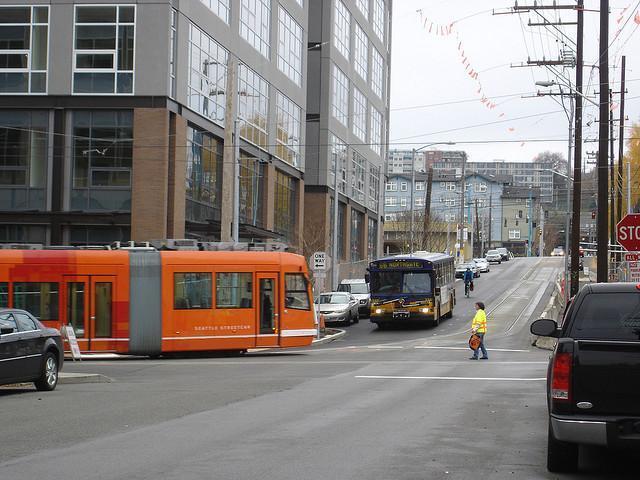How many cars can you see?
Give a very brief answer. 2. How many buses are there?
Give a very brief answer. 2. 